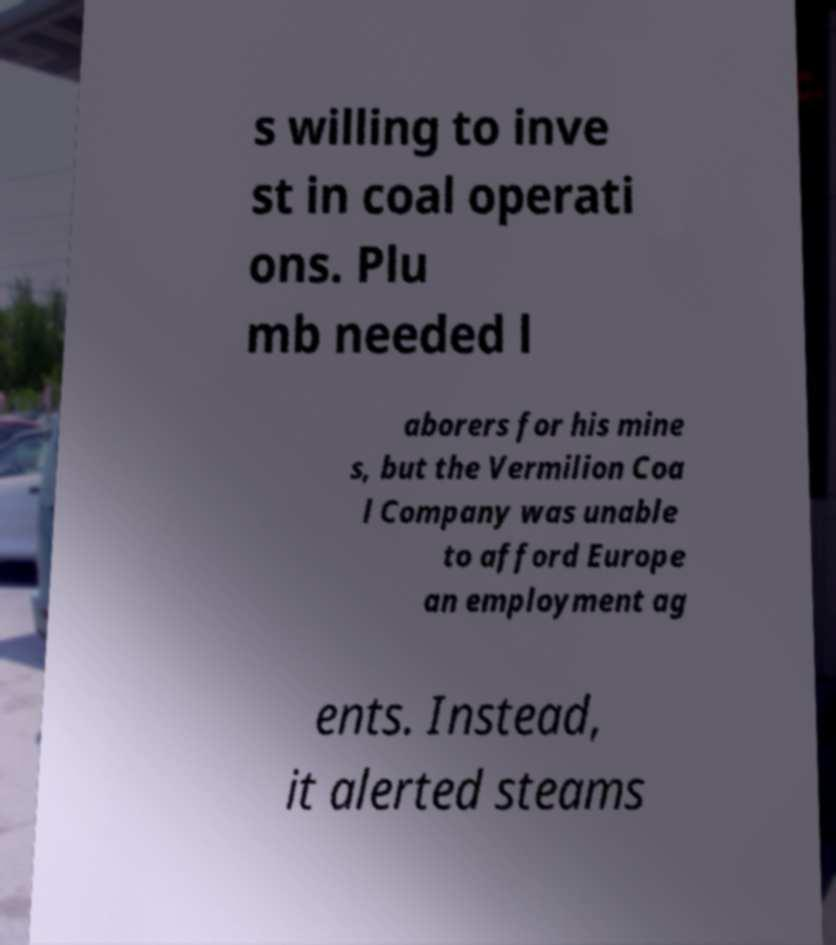Can you read and provide the text displayed in the image?This photo seems to have some interesting text. Can you extract and type it out for me? s willing to inve st in coal operati ons. Plu mb needed l aborers for his mine s, but the Vermilion Coa l Company was unable to afford Europe an employment ag ents. Instead, it alerted steams 